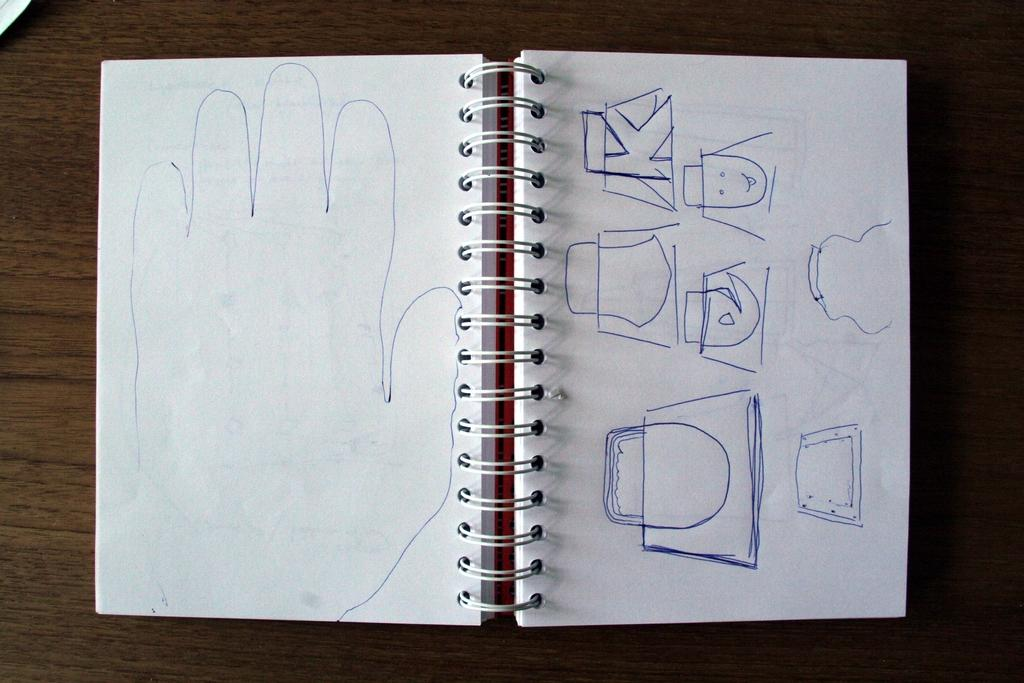What type of book is on the wooden surface in the image? There is a spiral book on a wooden surface in the image. What can be found on the papers in the image? The papers have images drawn on them. What type of fruit is hanging from the neck of the person in the image? There is no person or fruit present in the image; it only features a spiral book and papers with images drawn on them. 